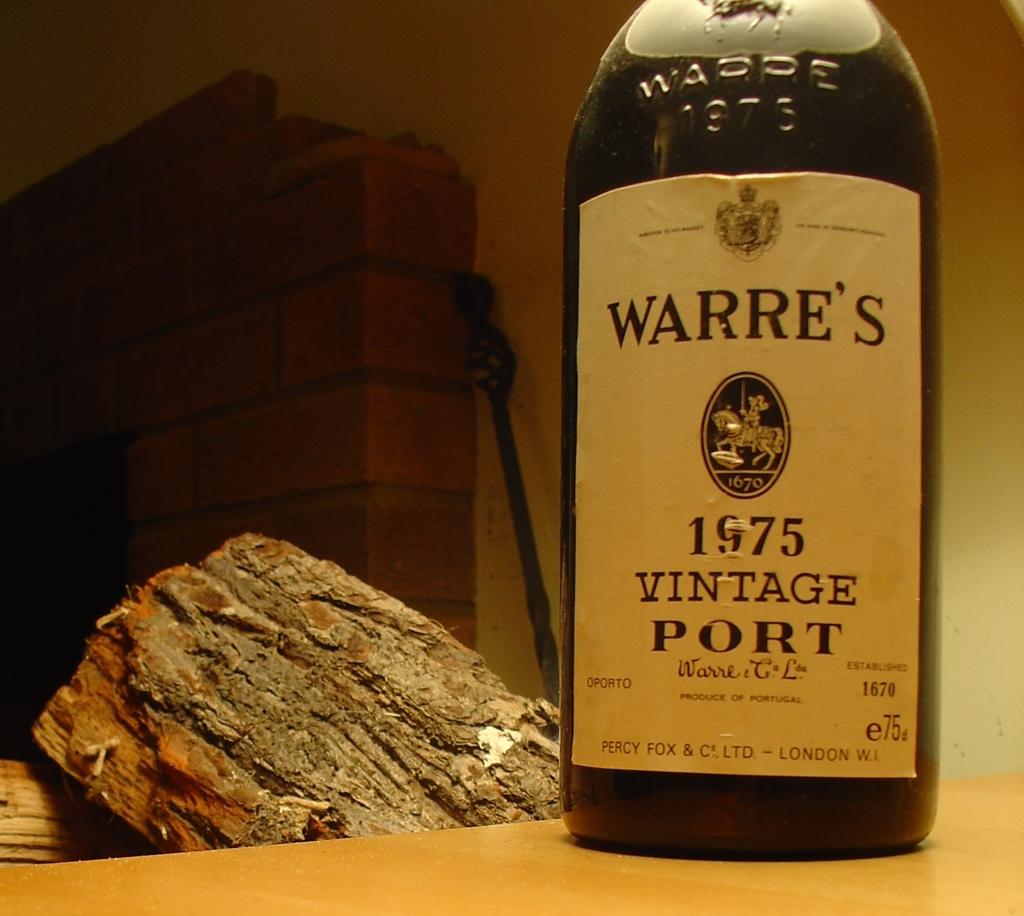Where was this bottle made in?
Give a very brief answer. London. What year is the beverage?
Your answer should be compact. 1975. 